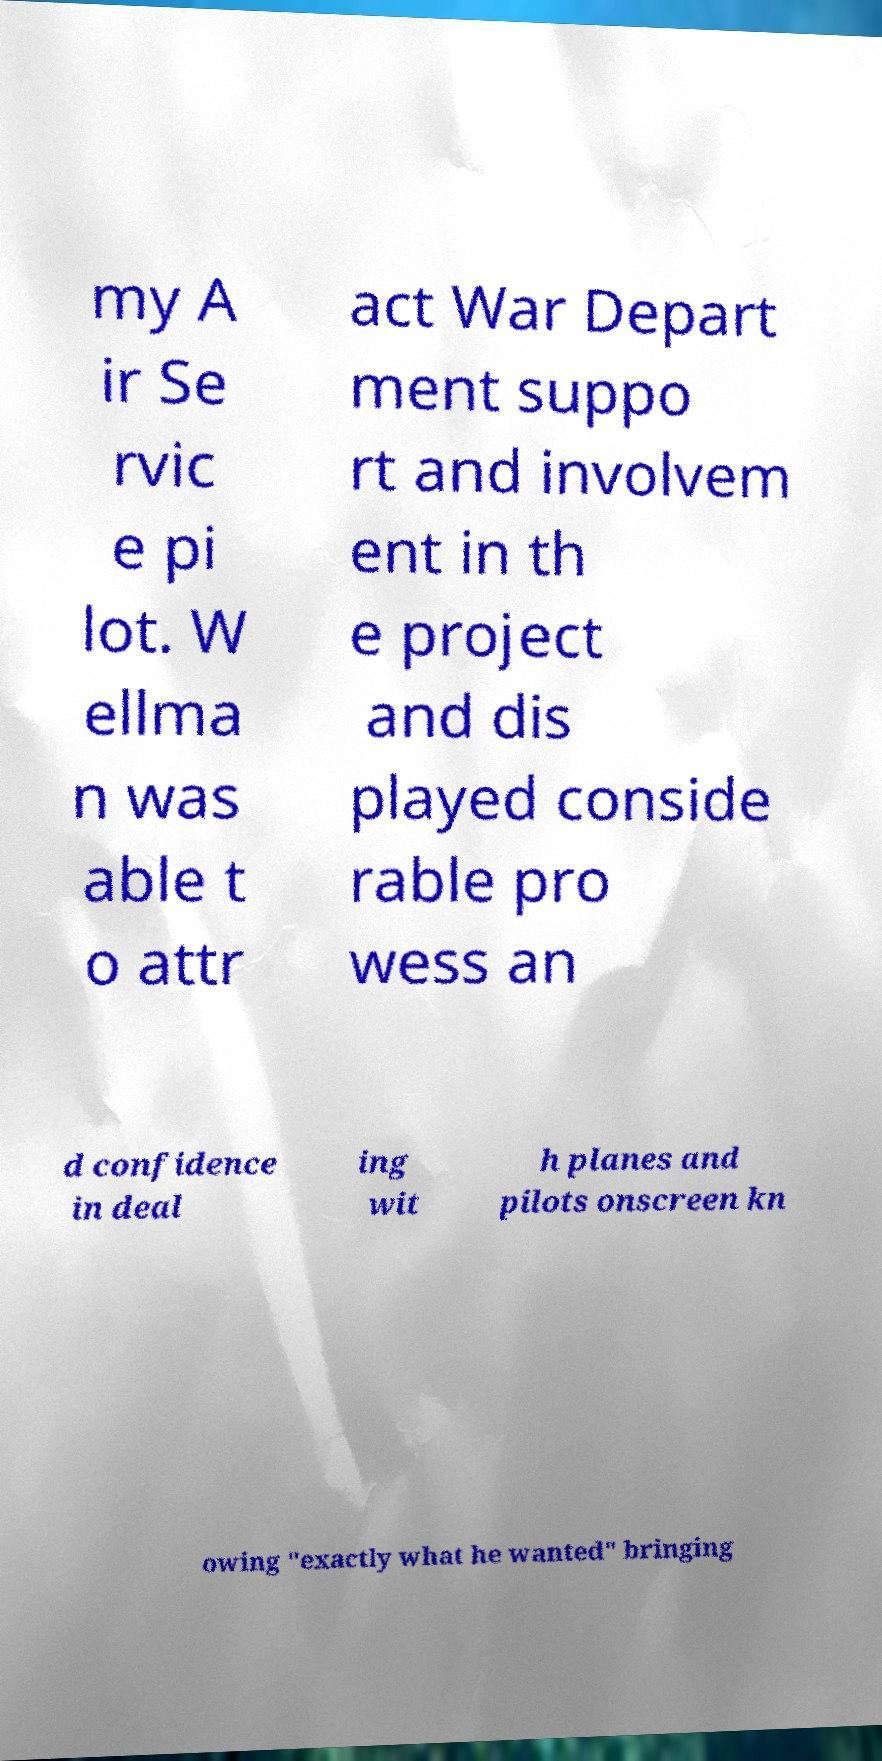I need the written content from this picture converted into text. Can you do that? my A ir Se rvic e pi lot. W ellma n was able t o attr act War Depart ment suppo rt and involvem ent in th e project and dis played conside rable pro wess an d confidence in deal ing wit h planes and pilots onscreen kn owing "exactly what he wanted" bringing 